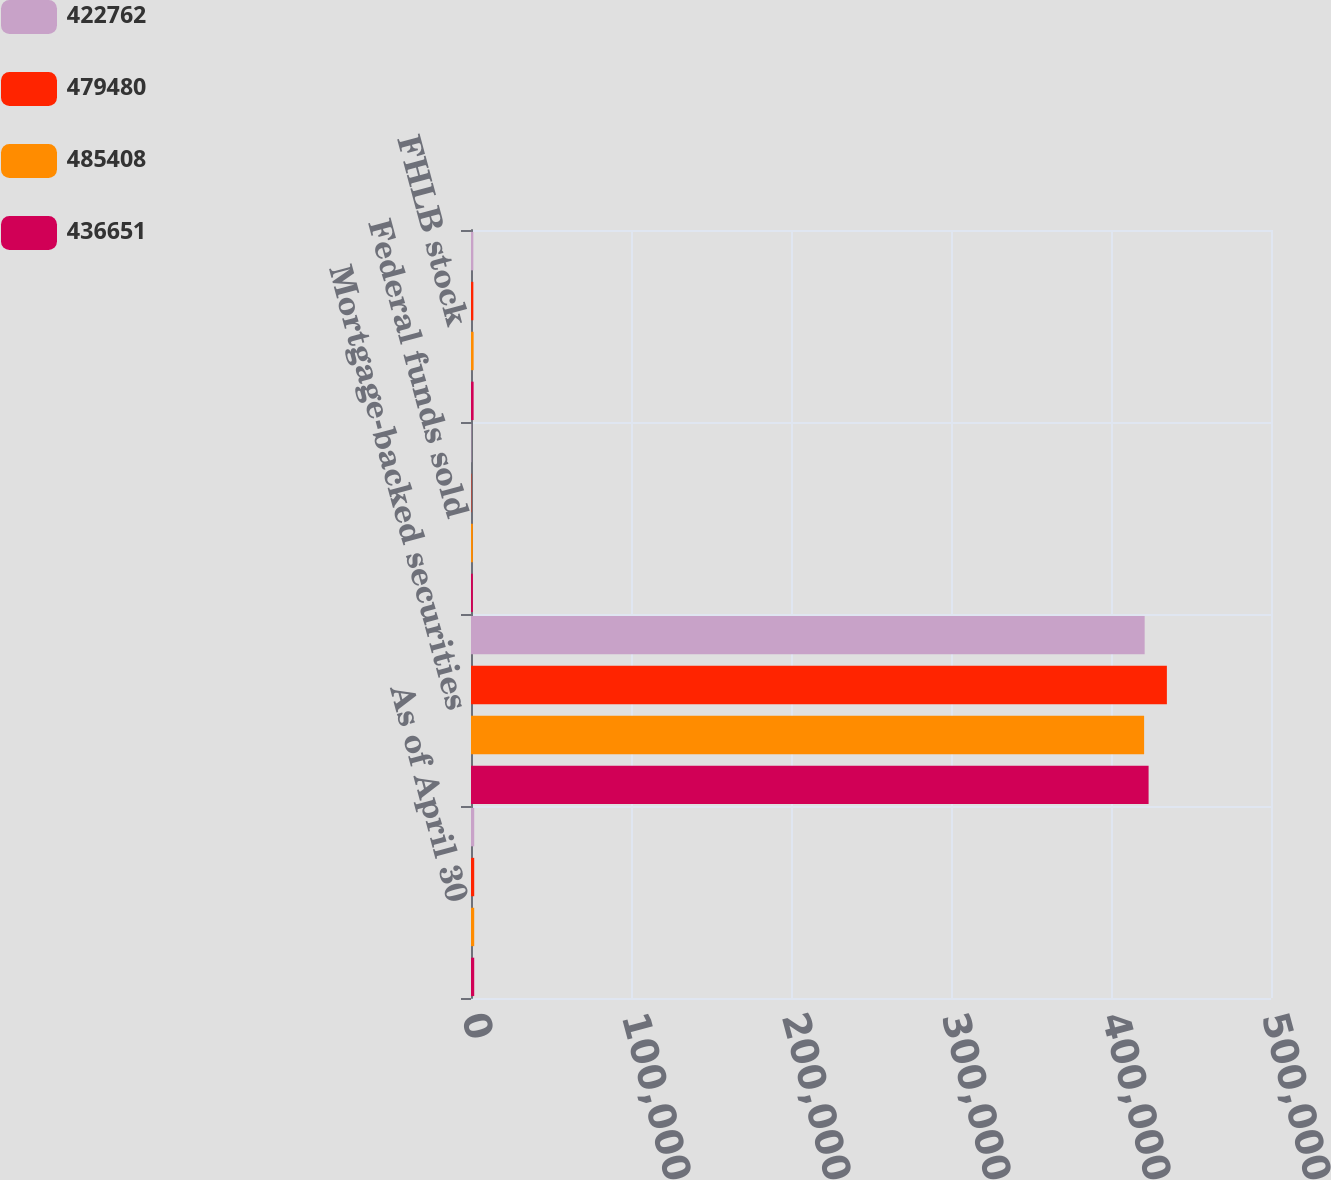Convert chart to OTSL. <chart><loc_0><loc_0><loc_500><loc_500><stacked_bar_chart><ecel><fcel>As of April 30<fcel>Mortgage-backed securities<fcel>Federal funds sold<fcel>FHLB stock<nl><fcel>422762<fcel>2015<fcel>421035<fcel>261<fcel>1466<nl><fcel>479480<fcel>2015<fcel>434924<fcel>261<fcel>1466<nl><fcel>485408<fcel>2014<fcel>420697<fcel>1156<fcel>1633<nl><fcel>436651<fcel>2014<fcel>423495<fcel>1156<fcel>1633<nl></chart> 